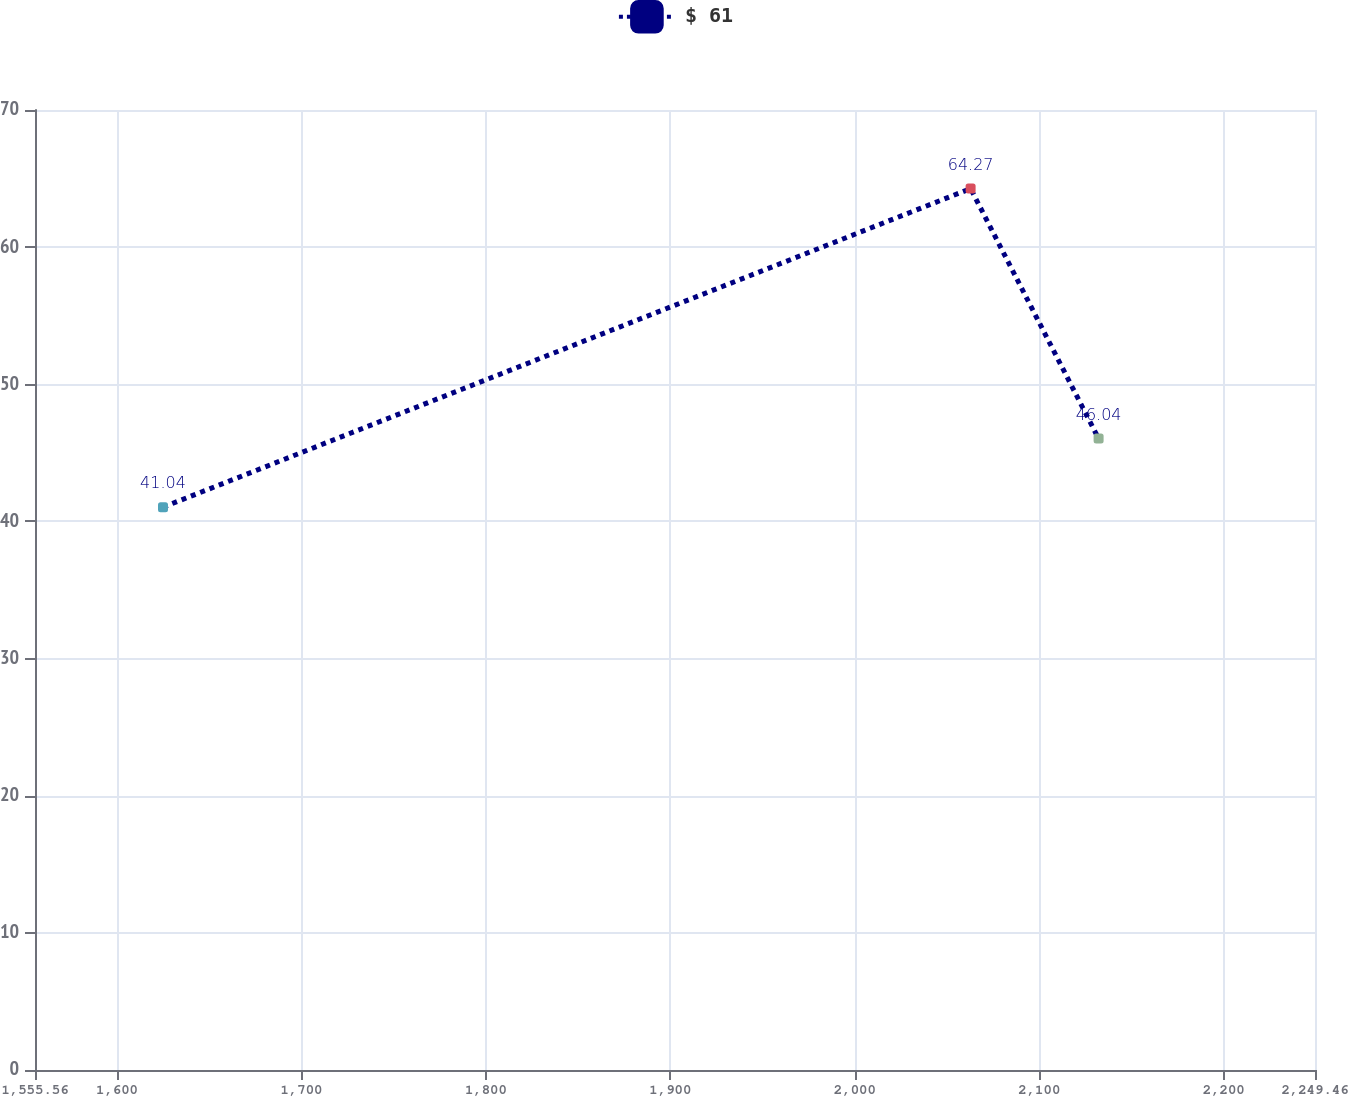Convert chart to OTSL. <chart><loc_0><loc_0><loc_500><loc_500><line_chart><ecel><fcel>$ 61<nl><fcel>1624.95<fcel>41.04<nl><fcel>2062.76<fcel>64.27<nl><fcel>2132.15<fcel>46.04<nl><fcel>2318.85<fcel>49.16<nl></chart> 